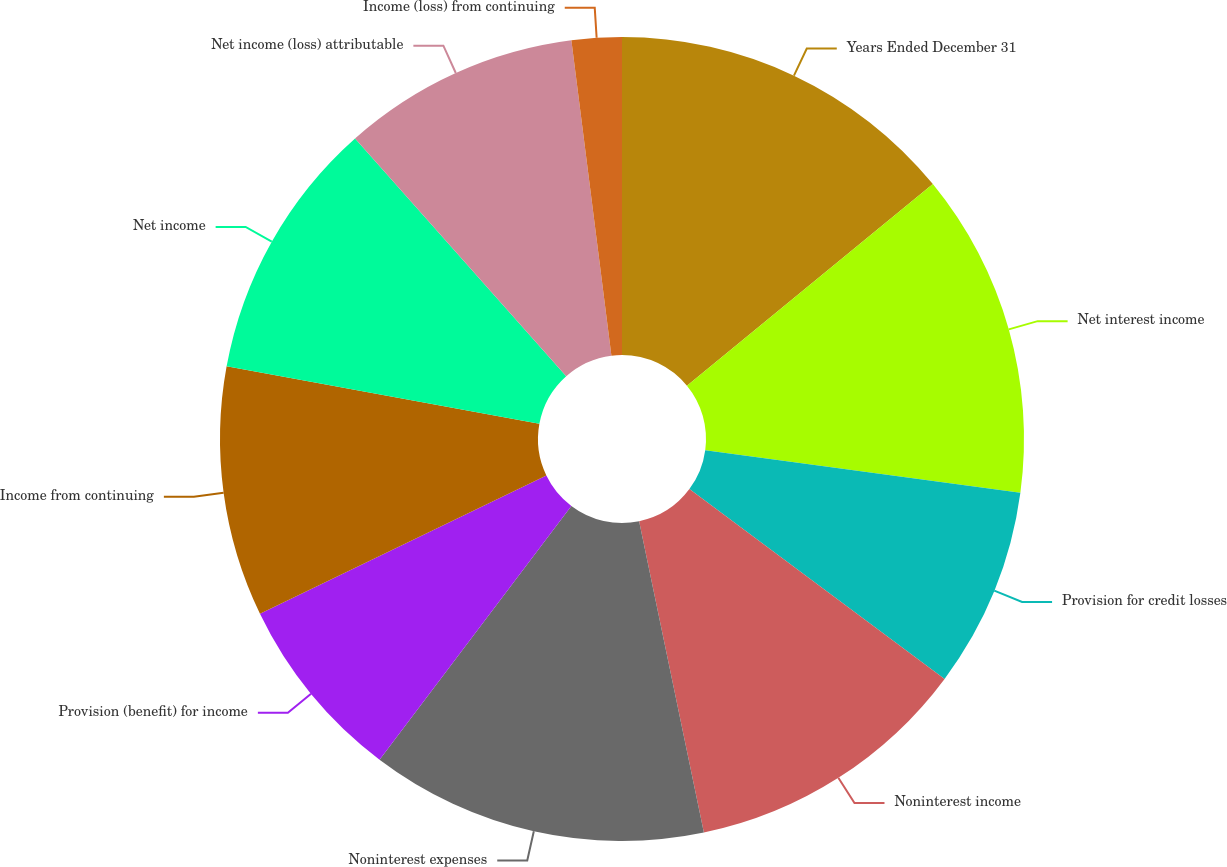Convert chart to OTSL. <chart><loc_0><loc_0><loc_500><loc_500><pie_chart><fcel>Years Ended December 31<fcel>Net interest income<fcel>Provision for credit losses<fcel>Noninterest income<fcel>Noninterest expenses<fcel>Provision (benefit) for income<fcel>Income from continuing<fcel>Net income<fcel>Net income (loss) attributable<fcel>Income (loss) from continuing<nl><fcel>14.07%<fcel>13.07%<fcel>8.04%<fcel>11.56%<fcel>13.57%<fcel>7.54%<fcel>10.05%<fcel>10.55%<fcel>9.55%<fcel>2.01%<nl></chart> 